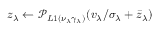Convert formula to latex. <formula><loc_0><loc_0><loc_500><loc_500>z _ { \lambda } \leftarrow \mathcal { P } _ { L 1 ( \nu _ { \lambda } \gamma _ { \lambda } ) } ( v _ { \lambda } / \sigma _ { \lambda } + \bar { z } _ { \lambda } )</formula> 